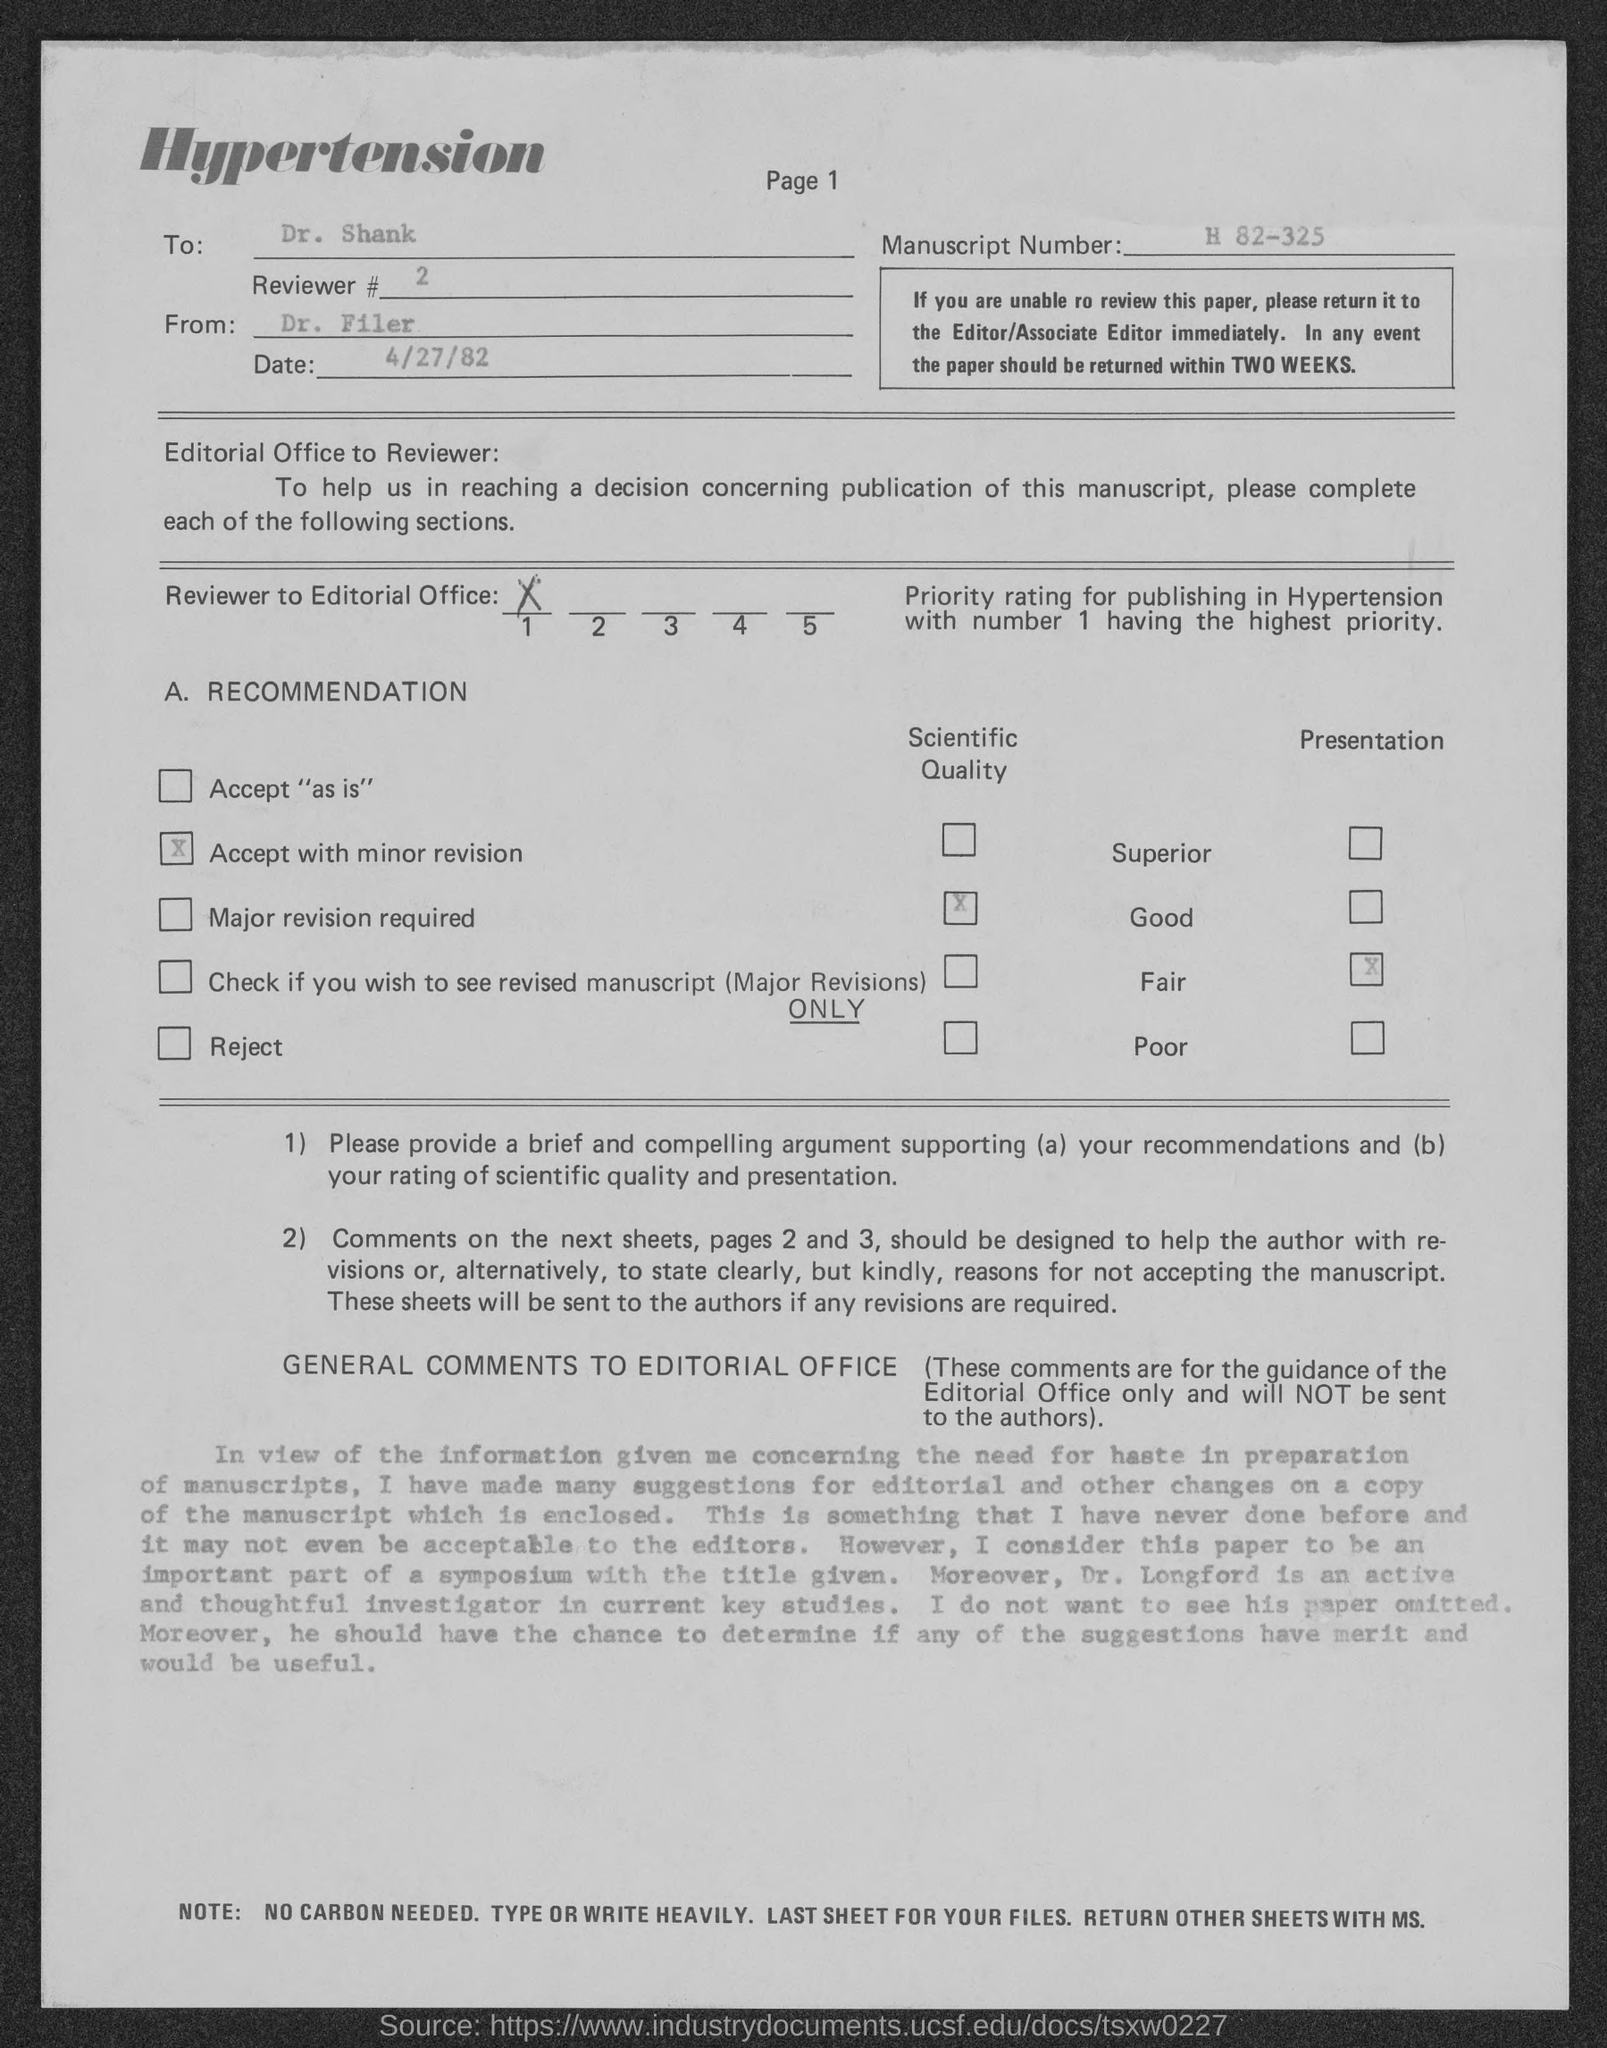Outline some significant characteristics in this image. The letter is addressed to Dr. Shank. The letter is dated April 27, 1982. The Manuscript Number is H 82-325. DR. FILER wrote the letter. 